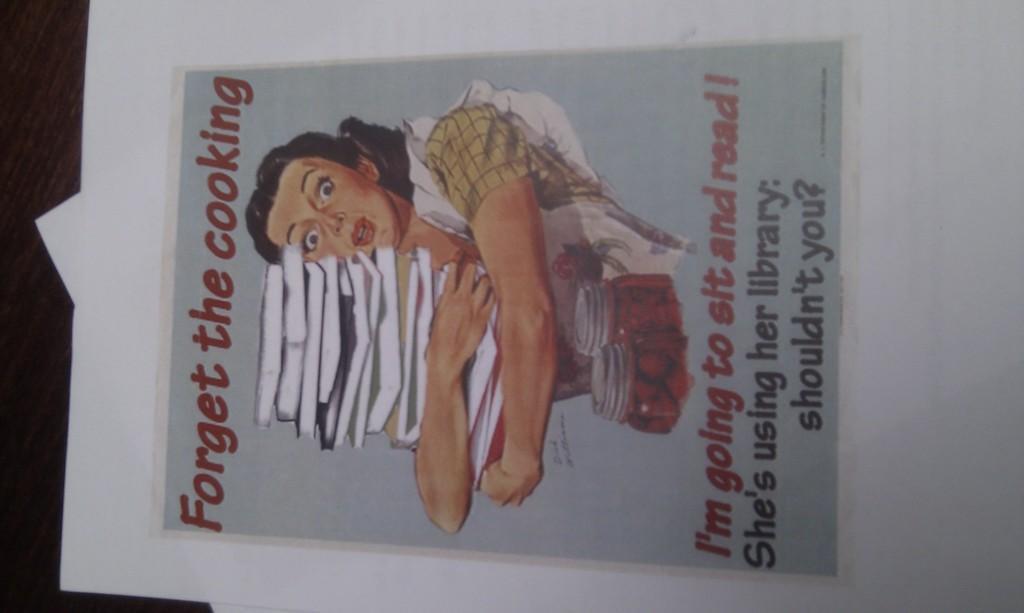In one or two sentences, can you explain what this image depicts? In this picture we can see book and papers on the table. In this paper we can see a woman who is holding many books, beside her we can see the two cans. On the right of the page we can see something is written. 